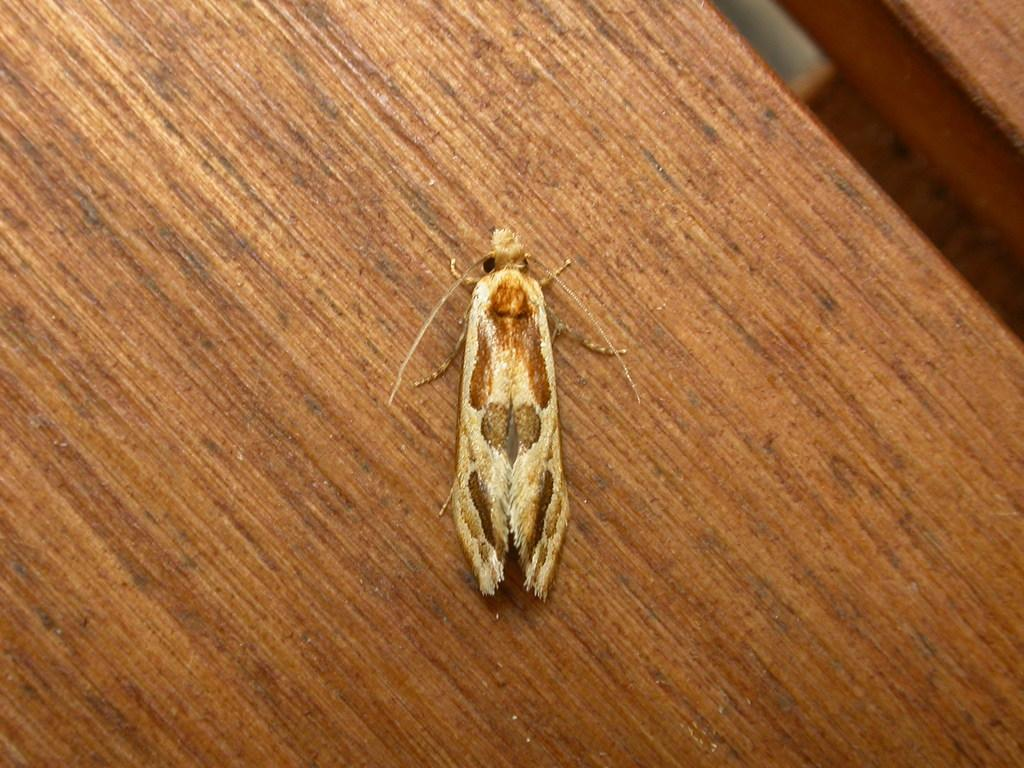What type of insect is present in the image? There is a moth in the image. What surface is the moth resting on? The moth is on a wooden object. Can you describe any objects visible in the top right corner of the image? Unfortunately, the provided facts do not mention any objects in the top right corner of the image. What type of quilt is being copied by the moth in the image? There is no quilt or copying activity present in the image; it features a moth on a wooden object. What type of spark can be seen coming from the moth in the image? There is no spark present in the image; it features a moth on a wooden object. 